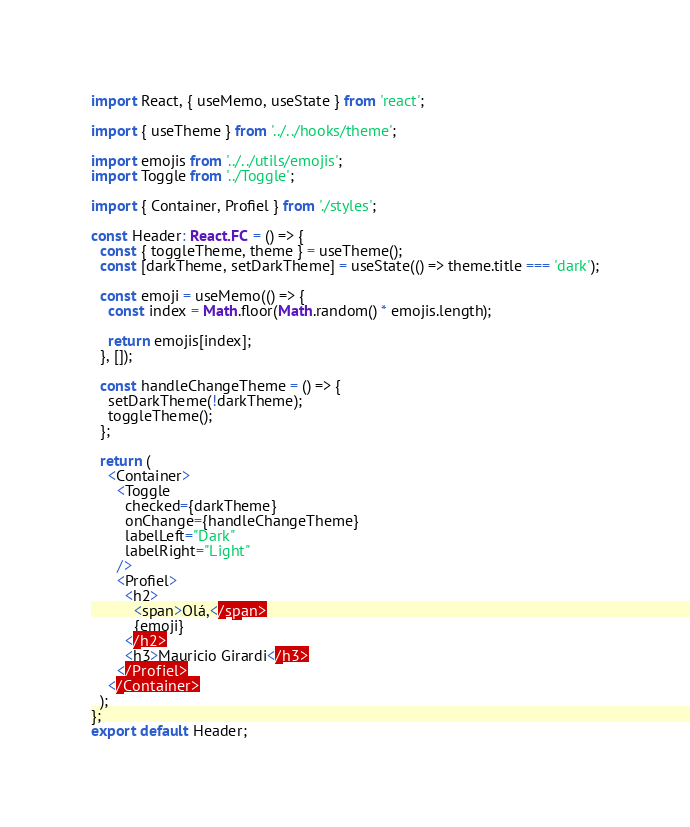<code> <loc_0><loc_0><loc_500><loc_500><_TypeScript_>import React, { useMemo, useState } from 'react';

import { useTheme } from '../../hooks/theme';

import emojis from '../../utils/emojis';
import Toggle from '../Toggle';

import { Container, Profiel } from './styles';

const Header: React.FC = () => {
  const { toggleTheme, theme } = useTheme();
  const [darkTheme, setDarkTheme] = useState(() => theme.title === 'dark');

  const emoji = useMemo(() => {
    const index = Math.floor(Math.random() * emojis.length);

    return emojis[index];
  }, []);

  const handleChangeTheme = () => {
    setDarkTheme(!darkTheme);
    toggleTheme();
  };

  return (
    <Container>
      <Toggle
        checked={darkTheme}
        onChange={handleChangeTheme}
        labelLeft="Dark"
        labelRight="Light"
      />
      <Profiel>
        <h2>
          <span>Olá,</span>
          {emoji}
        </h2>
        <h3>Mauricio Girardi</h3>
      </Profiel>
    </Container>
  );
};
export default Header;
</code> 